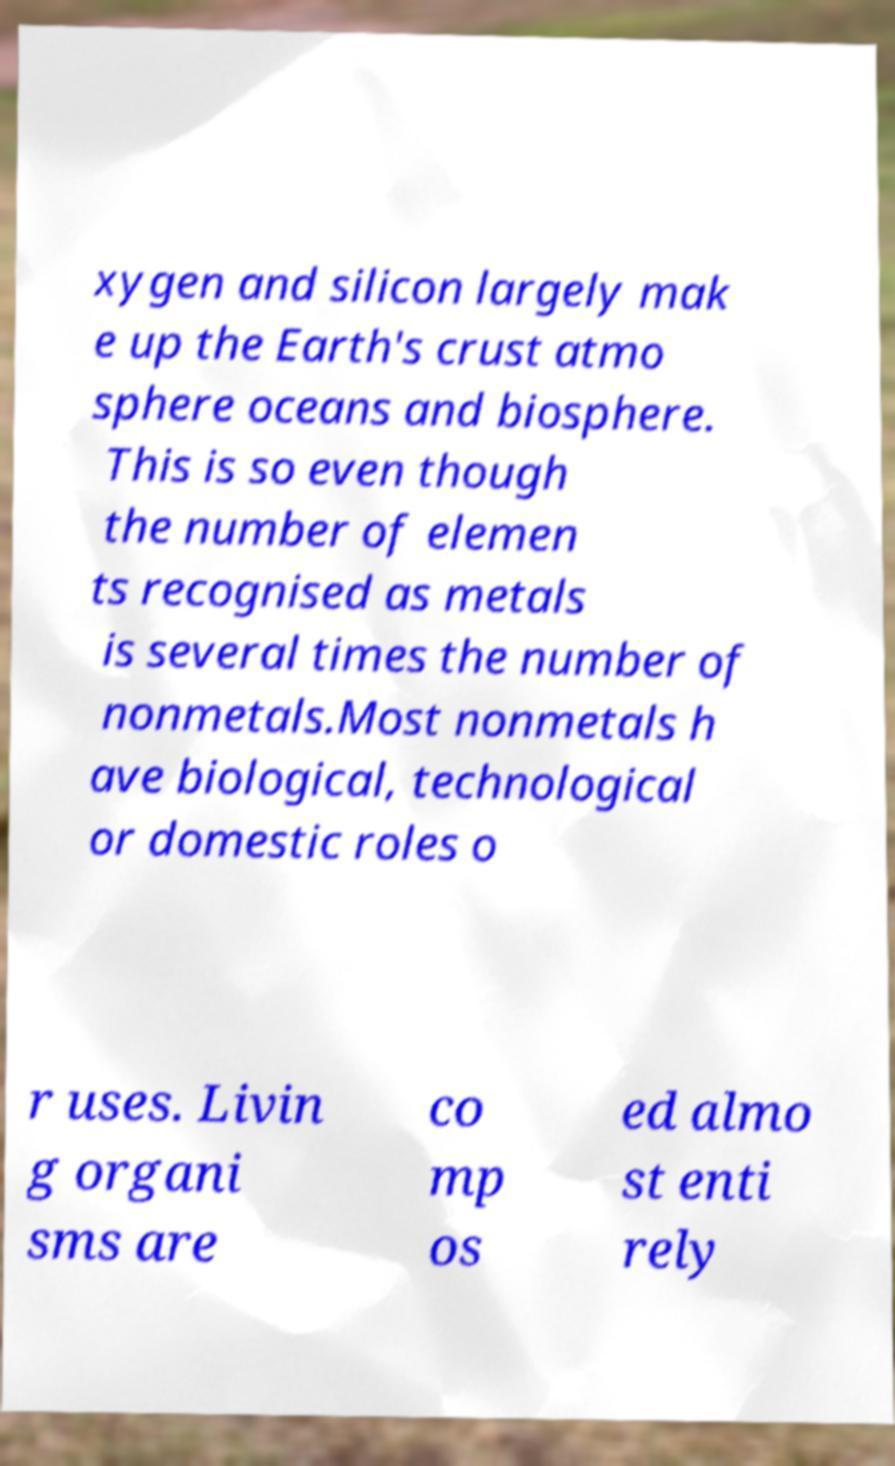There's text embedded in this image that I need extracted. Can you transcribe it verbatim? xygen and silicon largely mak e up the Earth's crust atmo sphere oceans and biosphere. This is so even though the number of elemen ts recognised as metals is several times the number of nonmetals.Most nonmetals h ave biological, technological or domestic roles o r uses. Livin g organi sms are co mp os ed almo st enti rely 